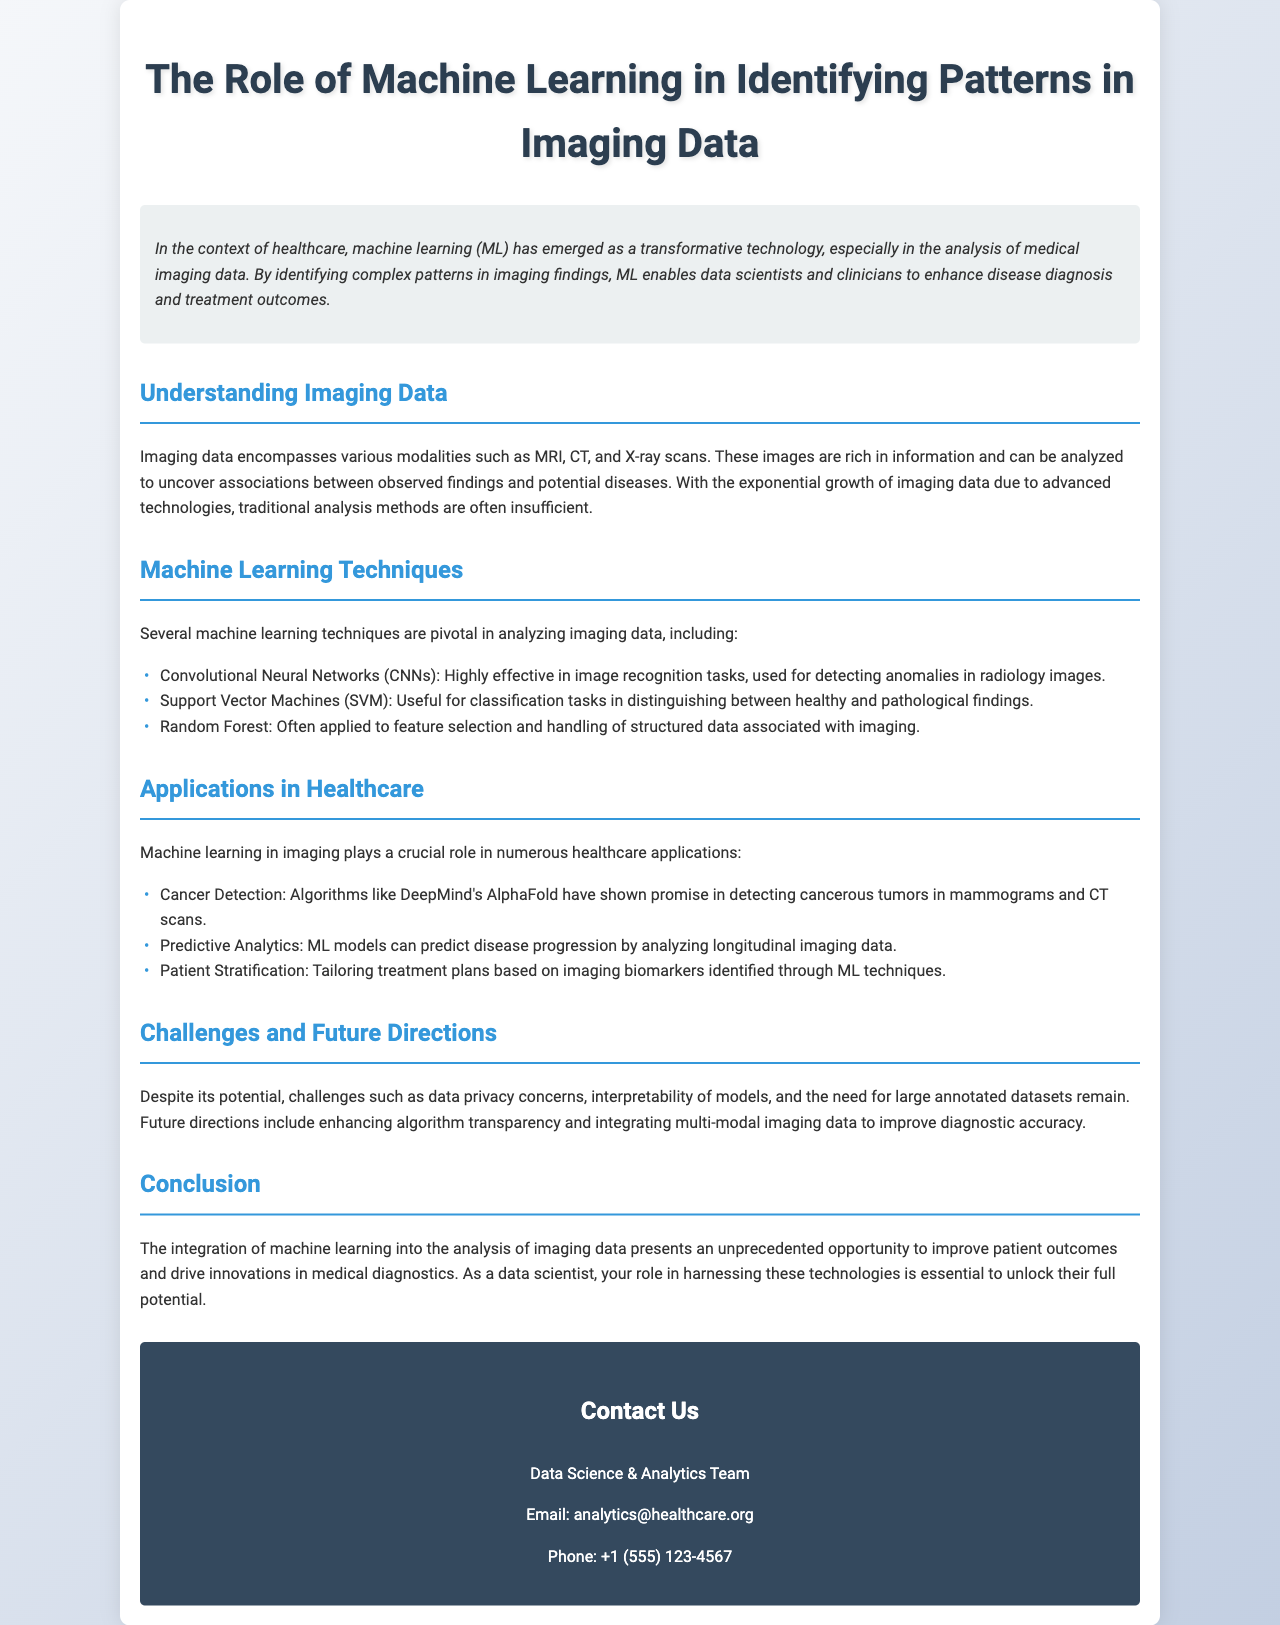What is the title of the document? The title of the document is presented at the top of the brochure.
Answer: The Role of Machine Learning in Identifying Patterns in Imaging Data What imaging modalities are mentioned? The document lists specific imaging modalities in the section about imaging data.
Answer: MRI, CT, and X-ray scans Which machine learning technique is effective for image recognition tasks? The document specifies that Convolutional Neural Networks are ideal for image recognition in medical imaging.
Answer: Convolutional Neural Networks What is a key application of machine learning in healthcare as noted in the document? The document highlights applications in healthcare, specifically cancer detection.
Answer: Cancer Detection What challenge does the document mention regarding machine learning in imaging? The document discusses challenges that exist in the integration of machine learning, specifically data privacy concerns.
Answer: Data privacy concerns How can machine learning assist in predictive analytics according to the document? The document states that ML models analyze longitudinal imaging data to make predictions.
Answer: By analyzing longitudinal imaging data Who should be contacted for more information? The contact section provides details on who to reach out to for further inquiries.
Answer: Data Science & Analytics Team 